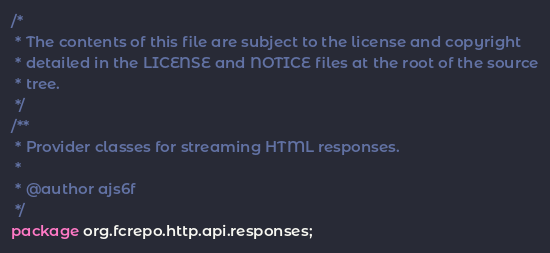Convert code to text. <code><loc_0><loc_0><loc_500><loc_500><_Java_>/*
 * The contents of this file are subject to the license and copyright
 * detailed in the LICENSE and NOTICE files at the root of the source
 * tree.
 */
/**
 * Provider classes for streaming HTML responses.
 *
 * @author ajs6f
 */
package org.fcrepo.http.api.responses;
</code> 